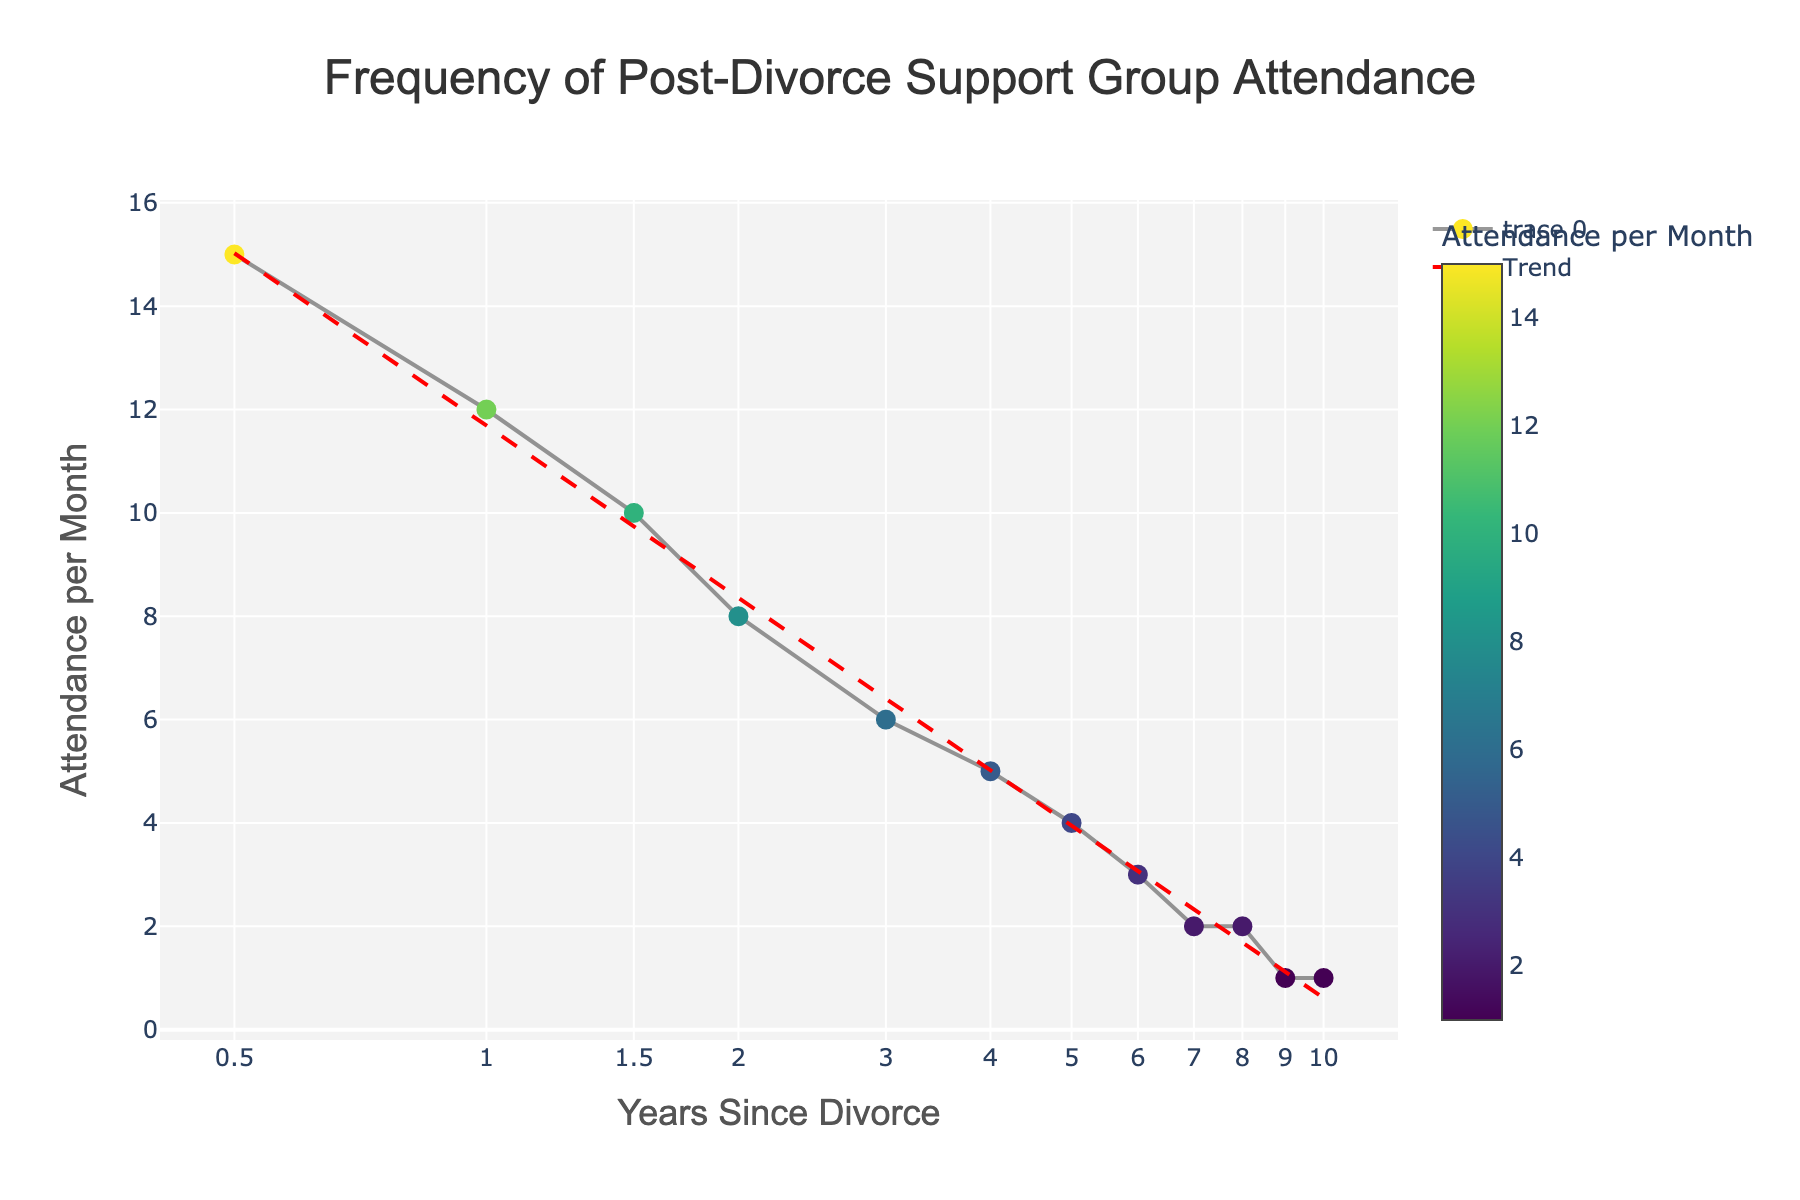What is the title of the plot? The title is displayed at the top of the plot in a large font, it reads 'Frequency of Post-Divorce Support Group Attendance.'
Answer: Frequency of Post-Divorce Support Group Attendance How many data points are shown in the plot? The plot shows individual points for each data entry. Counting these points, we see there are 12 data points.
Answer: 12 What is the range of the 'Years Since Divorce' axis? The 'Years Since Divorce' axis uses a log scale and ranges from 0.5 to 10 years, as indicated by the tick values on this axis.
Answer: 0.5 to 10 years Which year has the highest attendance per month? Looking at the y-axis and the scatter points, the highest attendance per month value of 15 occurs at 0.5 years since the divorce.
Answer: 0.5 years What is the attendance per month for 2 years since divorce? By locating the data point where 'Years Since Divorce' equals 2 on the x-axis, we can see that the corresponding attendance per month value on the y-axis is 8.
Answer: 8 What is the overall trend shown in the plot? The red dashed trend line helps indicate the overall trend. It shows a clear decrease in attendance per month as the years since divorce increase.
Answer: Decreasing What is the attendance difference between 1 year and 3 years since divorce? The attendance per month at 1 year since divorce is 12, and at 3 years since divorce, it is 6. Subtracting these values gives 12 - 6 = 6.
Answer: 6 Which year marks the first drop to 1 attendance per month? Checking along the x-axis for the first occurrence of the attendance per month being 1, it is marked at 9 years since divorce.
Answer: 9 years How does the attendance per month at 0.5 years compare to that at 10 years? The attendance per month at 0.5 years is 15, while at 10 years it is 1. Comparing these values, 15 is much greater than 1.
Answer: Greater at 0.5 years What is the average attendance per month over the first 5 years since divorce? The attendance values for the first 5 years are 15, 12, 10, 8, and 6. Summing these values gives 15 + 12 + 10 + 8 + 6 = 51. There are 5 years, so the average is 51 / 5 = 10.2.
Answer: 10.2 